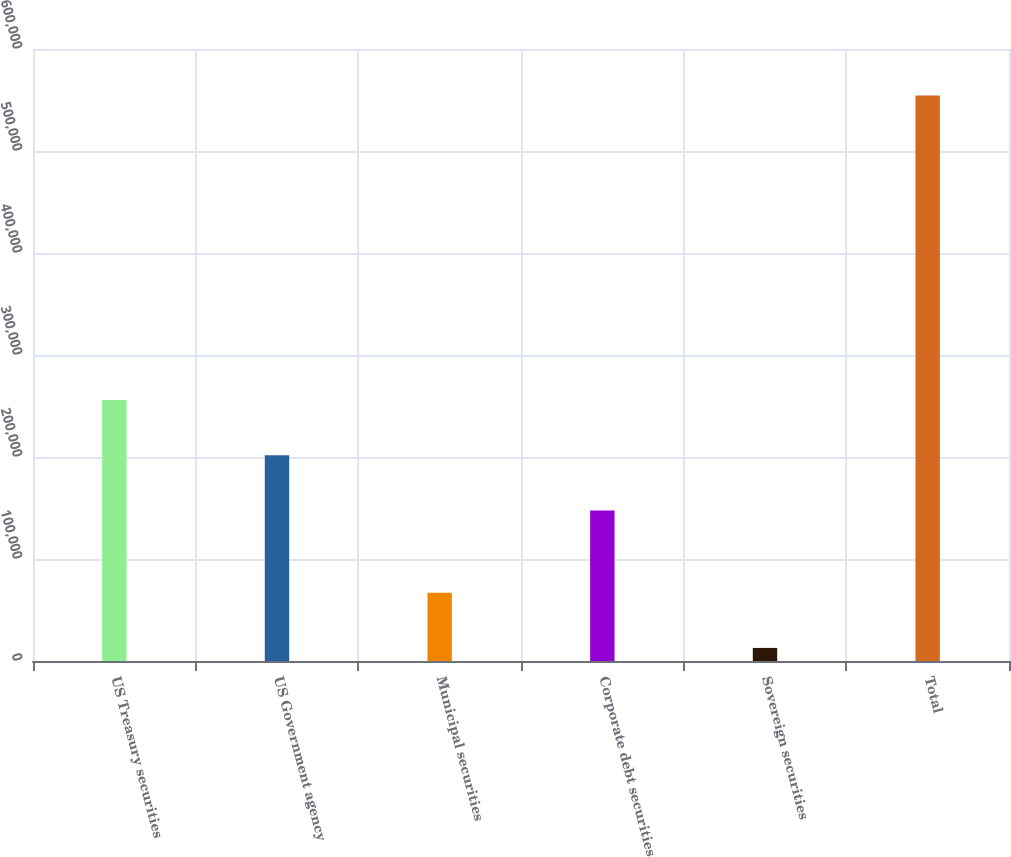Convert chart. <chart><loc_0><loc_0><loc_500><loc_500><bar_chart><fcel>US Treasury securities<fcel>US Government agency<fcel>Municipal securities<fcel>Corporate debt securities<fcel>Sovereign securities<fcel>Total<nl><fcel>255887<fcel>201721<fcel>66981.8<fcel>147555<fcel>12816<fcel>554474<nl></chart> 